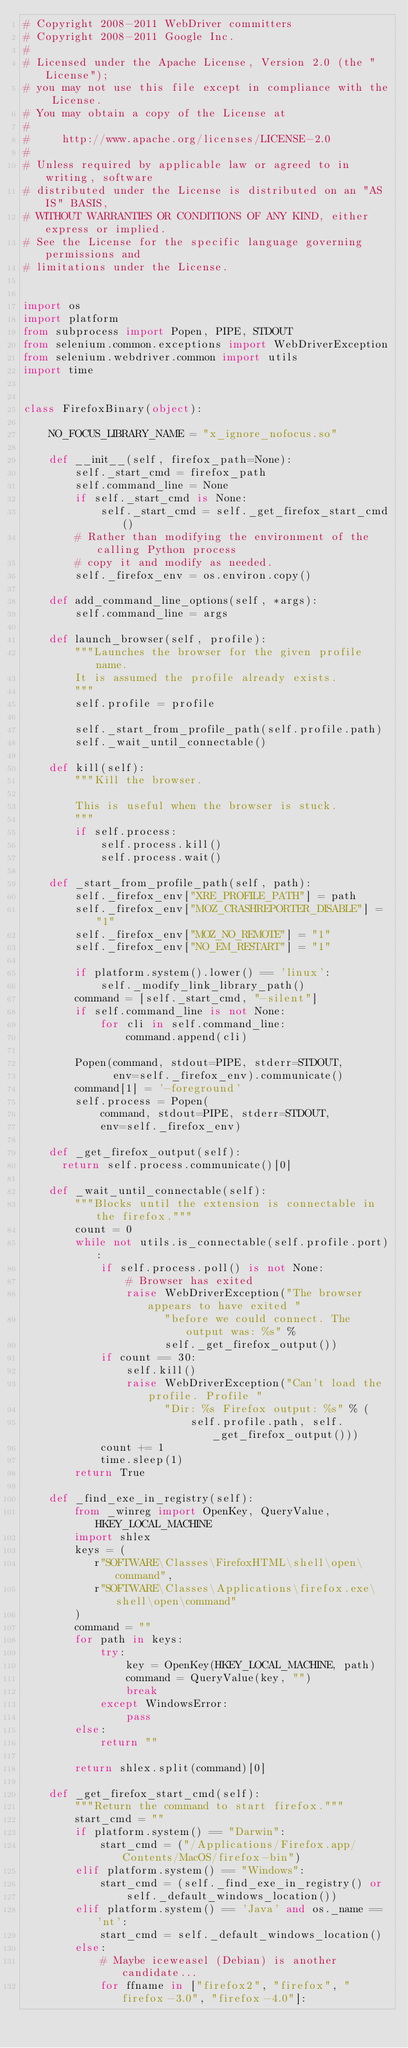Convert code to text. <code><loc_0><loc_0><loc_500><loc_500><_Python_># Copyright 2008-2011 WebDriver committers
# Copyright 2008-2011 Google Inc.
#
# Licensed under the Apache License, Version 2.0 (the "License");
# you may not use this file except in compliance with the License.
# You may obtain a copy of the License at
#
#     http://www.apache.org/licenses/LICENSE-2.0
#
# Unless required by applicable law or agreed to in writing, software
# distributed under the License is distributed on an "AS IS" BASIS,
# WITHOUT WARRANTIES OR CONDITIONS OF ANY KIND, either express or implied.
# See the License for the specific language governing permissions and
# limitations under the License.


import os
import platform
from subprocess import Popen, PIPE, STDOUT
from selenium.common.exceptions import WebDriverException
from selenium.webdriver.common import utils
import time


class FirefoxBinary(object):

    NO_FOCUS_LIBRARY_NAME = "x_ignore_nofocus.so"

    def __init__(self, firefox_path=None):
        self._start_cmd = firefox_path
        self.command_line = None
        if self._start_cmd is None:
            self._start_cmd = self._get_firefox_start_cmd()
        # Rather than modifying the environment of the calling Python process
        # copy it and modify as needed.
        self._firefox_env = os.environ.copy()

    def add_command_line_options(self, *args):
        self.command_line = args

    def launch_browser(self, profile):
        """Launches the browser for the given profile name.
        It is assumed the profile already exists.
        """
        self.profile = profile

        self._start_from_profile_path(self.profile.path)
        self._wait_until_connectable()
 
    def kill(self):
        """Kill the browser.

        This is useful when the browser is stuck.
        """
        if self.process:
            self.process.kill()
            self.process.wait()

    def _start_from_profile_path(self, path):
        self._firefox_env["XRE_PROFILE_PATH"] = path
        self._firefox_env["MOZ_CRASHREPORTER_DISABLE"] = "1"
        self._firefox_env["MOZ_NO_REMOTE"] = "1"
        self._firefox_env["NO_EM_RESTART"] = "1"

        if platform.system().lower() == 'linux':
            self._modify_link_library_path()
        command = [self._start_cmd, "-silent"]
        if self.command_line is not None:
            for cli in self.command_line:
                command.append(cli)

        Popen(command, stdout=PIPE, stderr=STDOUT,
              env=self._firefox_env).communicate()
        command[1] = '-foreground'
        self.process = Popen(
            command, stdout=PIPE, stderr=STDOUT,
            env=self._firefox_env)

    def _get_firefox_output(self):
      return self.process.communicate()[0]

    def _wait_until_connectable(self):
        """Blocks until the extension is connectable in the firefox."""
        count = 0
        while not utils.is_connectable(self.profile.port):
            if self.process.poll() is not None:
                # Browser has exited
                raise WebDriverException("The browser appears to have exited "
                      "before we could connect. The output was: %s" %
                      self._get_firefox_output())
            if count == 30:
                self.kill()
                raise WebDriverException("Can't load the profile. Profile "
                      "Dir: %s Firefox output: %s" % (
                          self.profile.path, self._get_firefox_output()))
            count += 1
            time.sleep(1)
        return True

    def _find_exe_in_registry(self):
        from _winreg import OpenKey, QueryValue, HKEY_LOCAL_MACHINE
        import shlex
        keys = (
           r"SOFTWARE\Classes\FirefoxHTML\shell\open\command",
           r"SOFTWARE\Classes\Applications\firefox.exe\shell\open\command"
        )
        command = ""
        for path in keys:
            try:
                key = OpenKey(HKEY_LOCAL_MACHINE, path)
                command = QueryValue(key, "")
                break
            except WindowsError:
                pass
        else:
            return ""
 
        return shlex.split(command)[0]

    def _get_firefox_start_cmd(self):
        """Return the command to start firefox."""
        start_cmd = ""
        if platform.system() == "Darwin":
            start_cmd = ("/Applications/Firefox.app/Contents/MacOS/firefox-bin")
        elif platform.system() == "Windows":
            start_cmd = (self._find_exe_in_registry() or 
                self._default_windows_location())
        elif platform.system() == 'Java' and os._name == 'nt':
            start_cmd = self._default_windows_location()
        else:
            # Maybe iceweasel (Debian) is another candidate...
            for ffname in ["firefox2", "firefox", "firefox-3.0", "firefox-4.0"]:</code> 